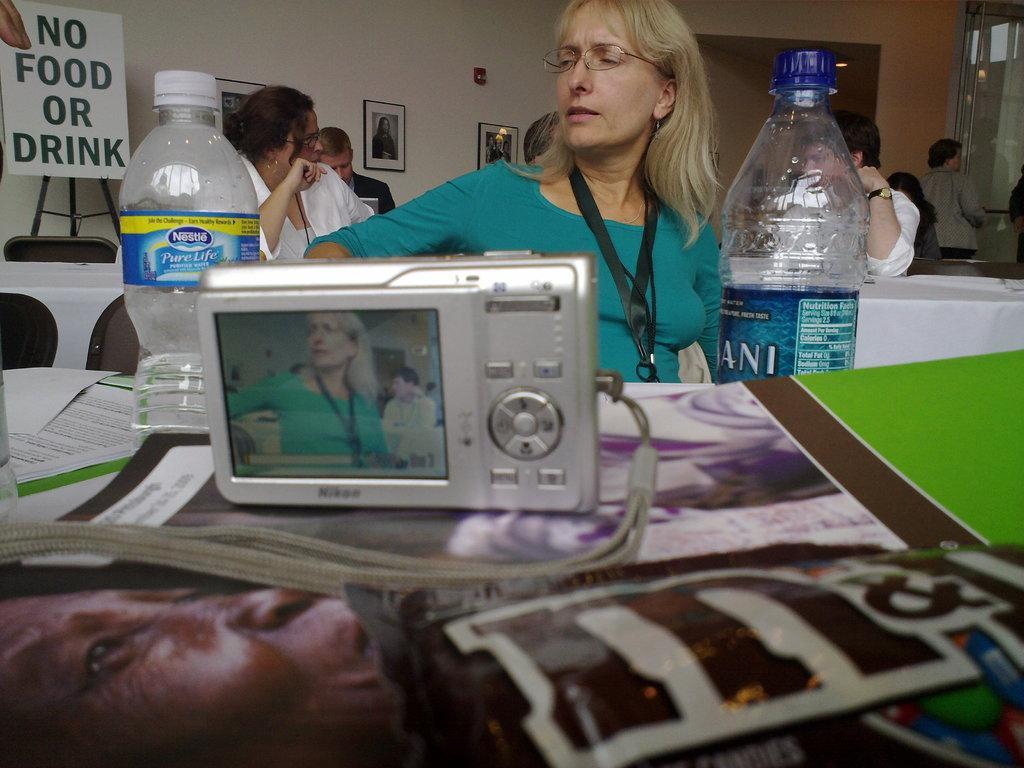In one or two sentences, can you explain what this image depicts? Here in the front we can see a camera present on a table and women in front of the camera and there are couple of bottles present and behind her we can see a group of people sitting and on the left top we can see a board written as no food or drink on it 